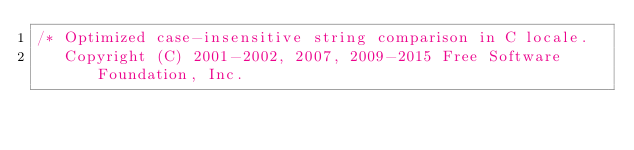Convert code to text. <code><loc_0><loc_0><loc_500><loc_500><_C_>/* Optimized case-insensitive string comparison in C locale.
   Copyright (C) 2001-2002, 2007, 2009-2015 Free Software Foundation, Inc.
</code> 